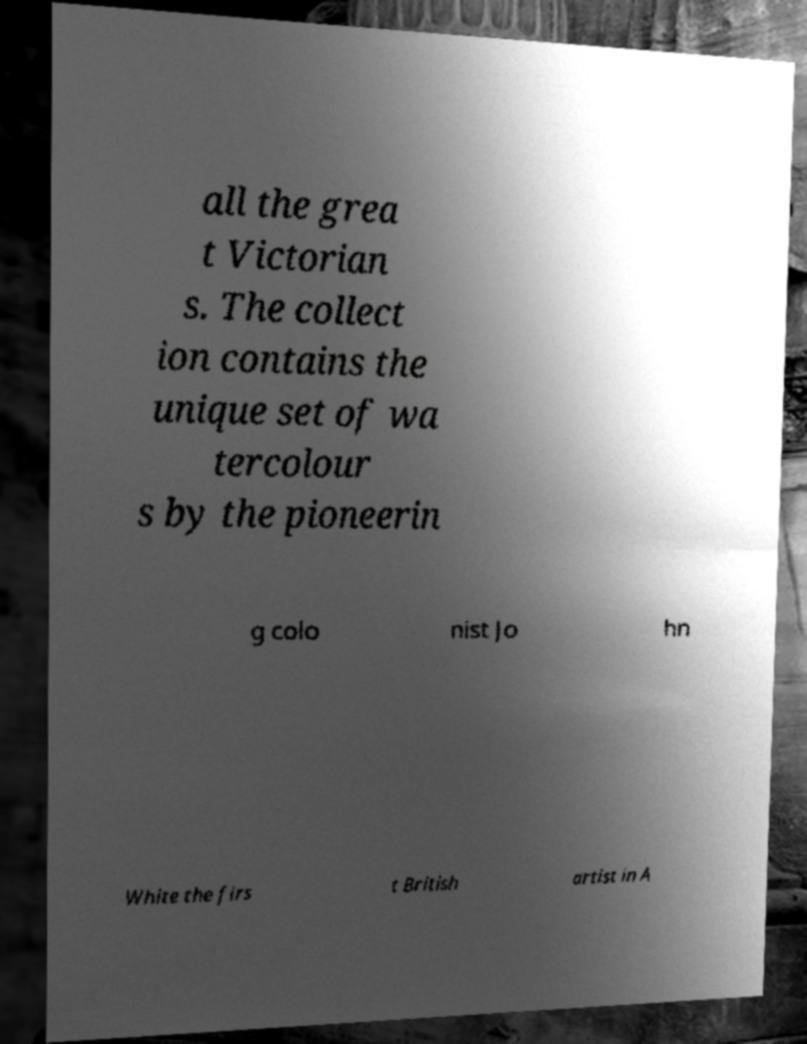Can you read and provide the text displayed in the image?This photo seems to have some interesting text. Can you extract and type it out for me? all the grea t Victorian s. The collect ion contains the unique set of wa tercolour s by the pioneerin g colo nist Jo hn White the firs t British artist in A 